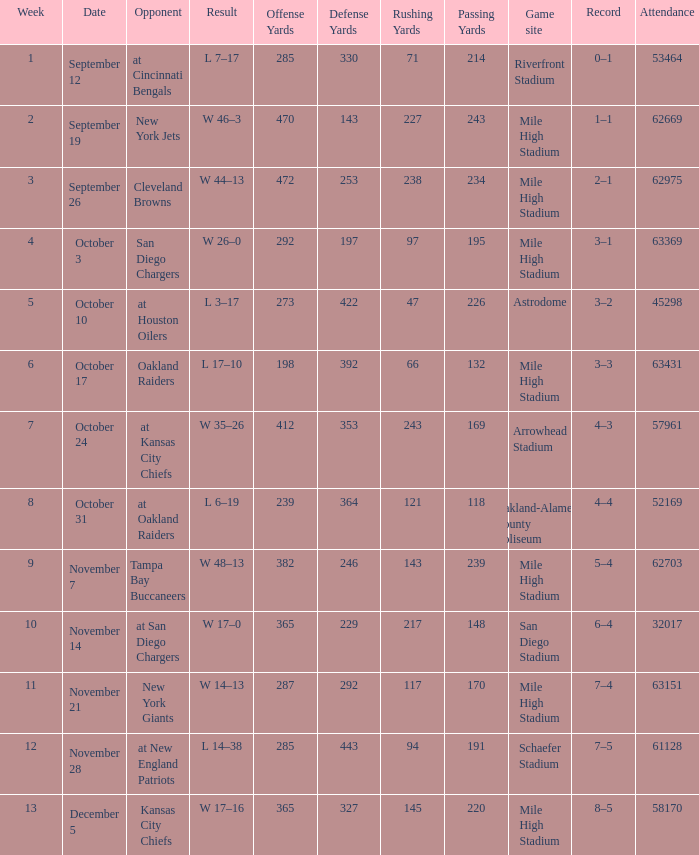What was the date of the week 4 game? October 3. 